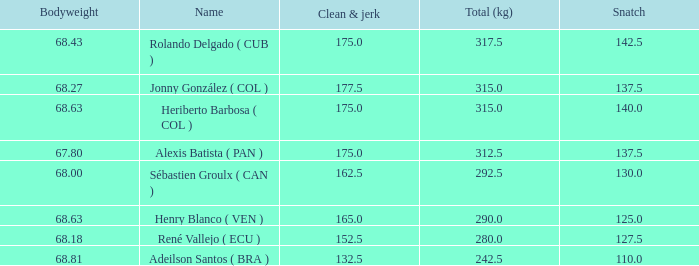Name the average clean and jerk for snatch of 140 and total kg less than 315 None. 